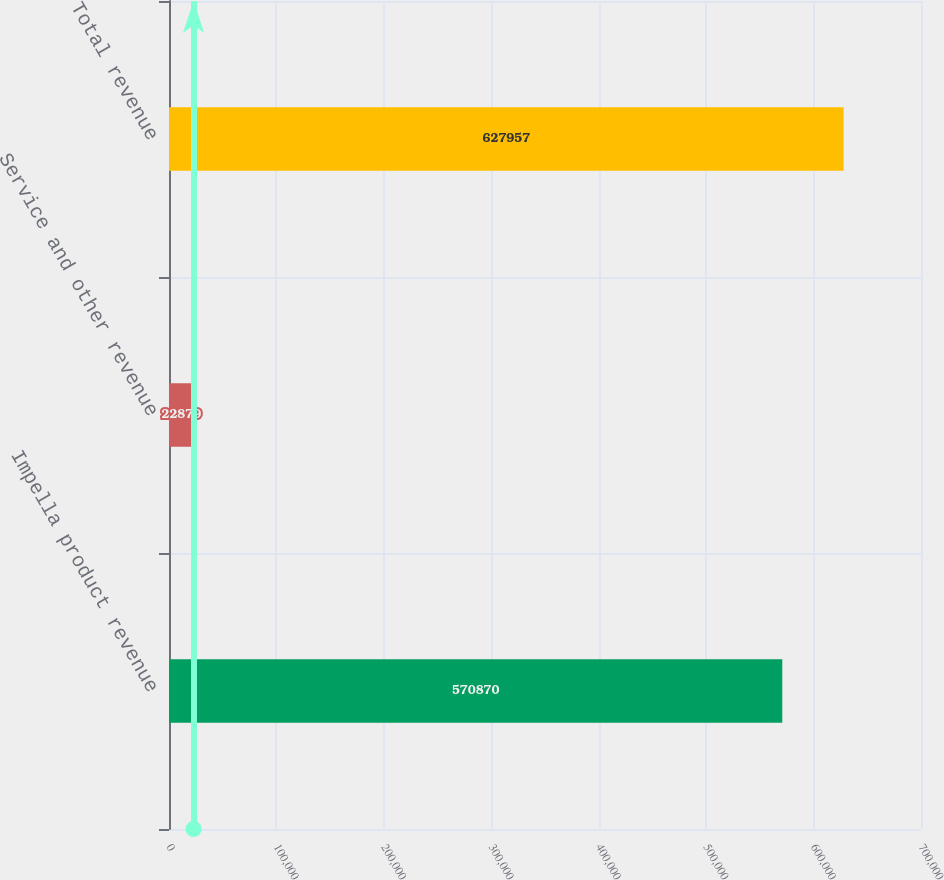Convert chart. <chart><loc_0><loc_0><loc_500><loc_500><bar_chart><fcel>Impella product revenue<fcel>Service and other revenue<fcel>Total revenue<nl><fcel>570870<fcel>22879<fcel>627957<nl></chart> 